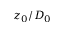<formula> <loc_0><loc_0><loc_500><loc_500>z _ { 0 } / D _ { 0 }</formula> 